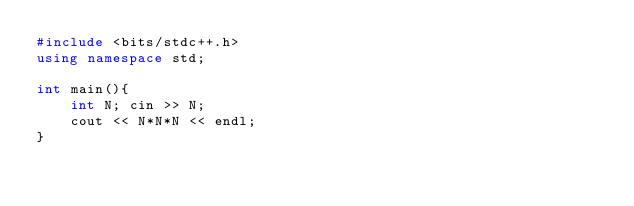<code> <loc_0><loc_0><loc_500><loc_500><_C++_>#include <bits/stdc++.h>
using namespace std;

int main(){
	int N; cin >> N;
	cout << N*N*N << endl;
}
</code> 